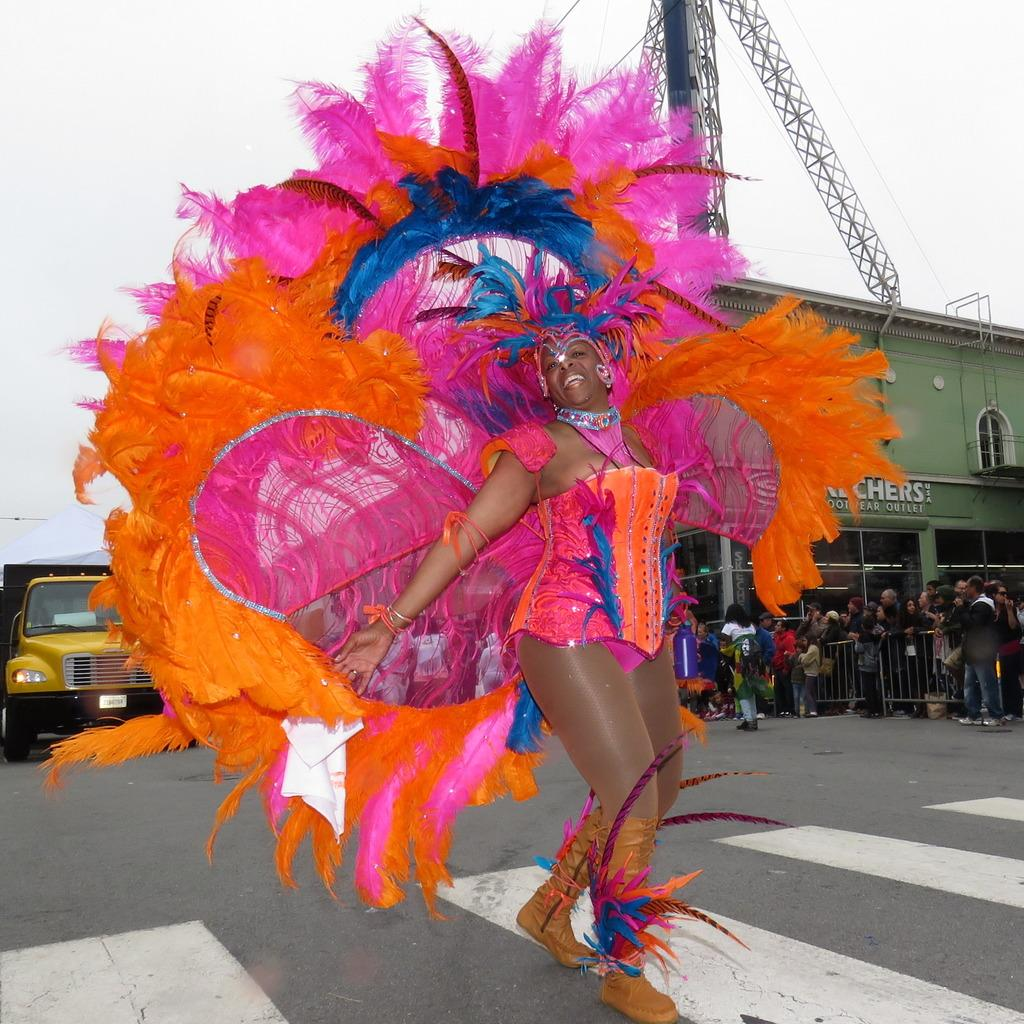Who is present in the image? There is a woman in the image. What is the woman doing in the image? The woman is walking with a smile on her face. What can be seen behind the woman? There is a truck behind the woman. What activity is taking place in front of the building? There are people standing in a queue in front of a building. What type of wall can be seen in the image? There is no wall present in the image. How many rails are visible in the image? There are no rails visible in the image. 